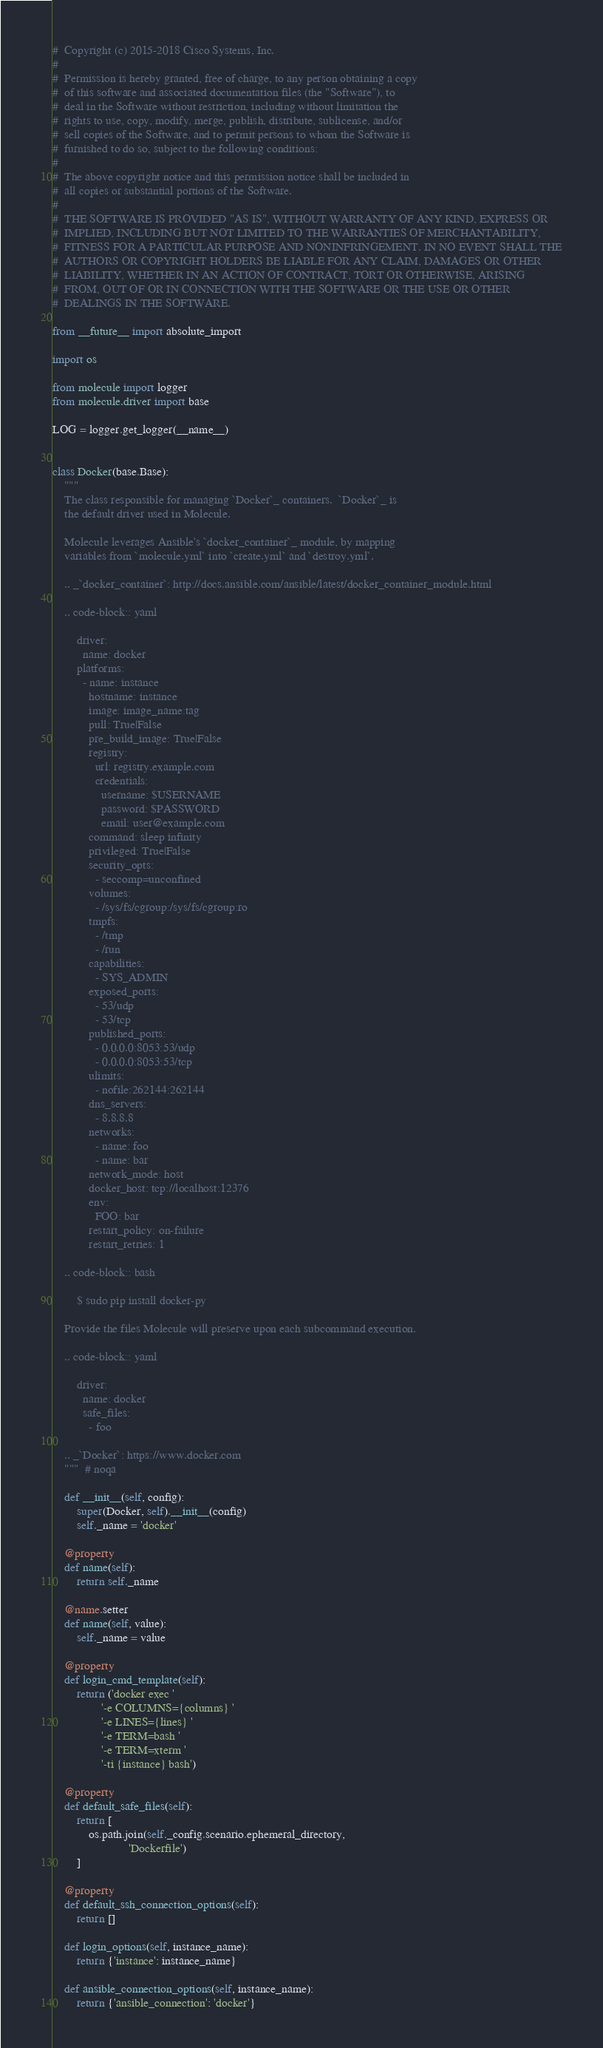Convert code to text. <code><loc_0><loc_0><loc_500><loc_500><_Python_>#  Copyright (c) 2015-2018 Cisco Systems, Inc.
#
#  Permission is hereby granted, free of charge, to any person obtaining a copy
#  of this software and associated documentation files (the "Software"), to
#  deal in the Software without restriction, including without limitation the
#  rights to use, copy, modify, merge, publish, distribute, sublicense, and/or
#  sell copies of the Software, and to permit persons to whom the Software is
#  furnished to do so, subject to the following conditions:
#
#  The above copyright notice and this permission notice shall be included in
#  all copies or substantial portions of the Software.
#
#  THE SOFTWARE IS PROVIDED "AS IS", WITHOUT WARRANTY OF ANY KIND, EXPRESS OR
#  IMPLIED, INCLUDING BUT NOT LIMITED TO THE WARRANTIES OF MERCHANTABILITY,
#  FITNESS FOR A PARTICULAR PURPOSE AND NONINFRINGEMENT. IN NO EVENT SHALL THE
#  AUTHORS OR COPYRIGHT HOLDERS BE LIABLE FOR ANY CLAIM, DAMAGES OR OTHER
#  LIABILITY, WHETHER IN AN ACTION OF CONTRACT, TORT OR OTHERWISE, ARISING
#  FROM, OUT OF OR IN CONNECTION WITH THE SOFTWARE OR THE USE OR OTHER
#  DEALINGS IN THE SOFTWARE.

from __future__ import absolute_import

import os

from molecule import logger
from molecule.driver import base

LOG = logger.get_logger(__name__)


class Docker(base.Base):
    """
    The class responsible for managing `Docker`_ containers.  `Docker`_ is
    the default driver used in Molecule.

    Molecule leverages Ansible's `docker_container`_ module, by mapping
    variables from `molecule.yml` into `create.yml` and `destroy.yml`.

    .. _`docker_container`: http://docs.ansible.com/ansible/latest/docker_container_module.html

    .. code-block:: yaml

        driver:
          name: docker
        platforms:
          - name: instance
            hostname: instance
            image: image_name:tag
            pull: True|False
            pre_build_image: True|False
            registry:
              url: registry.example.com
              credentials:
                username: $USERNAME
                password: $PASSWORD
                email: user@example.com
            command: sleep infinity
            privileged: True|False
            security_opts:
              - seccomp=unconfined
            volumes:
              - /sys/fs/cgroup:/sys/fs/cgroup:ro
            tmpfs:
              - /tmp
              - /run
            capabilities:
              - SYS_ADMIN
            exposed_ports:
              - 53/udp
              - 53/tcp
            published_ports:
              - 0.0.0.0:8053:53/udp
              - 0.0.0.0:8053:53/tcp
            ulimits:
              - nofile:262144:262144
            dns_servers:
              - 8.8.8.8
            networks:
              - name: foo
              - name: bar
            network_mode: host
            docker_host: tcp://localhost:12376
            env:
              FOO: bar
            restart_policy: on-failure
            restart_retries: 1

    .. code-block:: bash

        $ sudo pip install docker-py

    Provide the files Molecule will preserve upon each subcommand execution.

    .. code-block:: yaml

        driver:
          name: docker
          safe_files:
            - foo

    .. _`Docker`: https://www.docker.com
    """  # noqa

    def __init__(self, config):
        super(Docker, self).__init__(config)
        self._name = 'docker'

    @property
    def name(self):
        return self._name

    @name.setter
    def name(self, value):
        self._name = value

    @property
    def login_cmd_template(self):
        return ('docker exec '
                '-e COLUMNS={columns} '
                '-e LINES={lines} '
                '-e TERM=bash '
                '-e TERM=xterm '
                '-ti {instance} bash')

    @property
    def default_safe_files(self):
        return [
            os.path.join(self._config.scenario.ephemeral_directory,
                         'Dockerfile')
        ]

    @property
    def default_ssh_connection_options(self):
        return []

    def login_options(self, instance_name):
        return {'instance': instance_name}

    def ansible_connection_options(self, instance_name):
        return {'ansible_connection': 'docker'}
</code> 